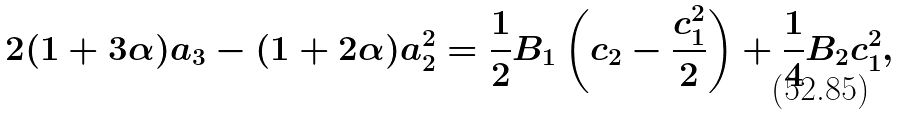<formula> <loc_0><loc_0><loc_500><loc_500>2 ( 1 + 3 \alpha ) a _ { 3 } - ( 1 + 2 \alpha ) a _ { 2 } ^ { 2 } = \frac { 1 } { 2 } B _ { 1 } \left ( c _ { 2 } - \frac { c _ { 1 } ^ { 2 } } { 2 } \right ) + \frac { 1 } { 4 } B _ { 2 } c _ { 1 } ^ { 2 } ,</formula> 